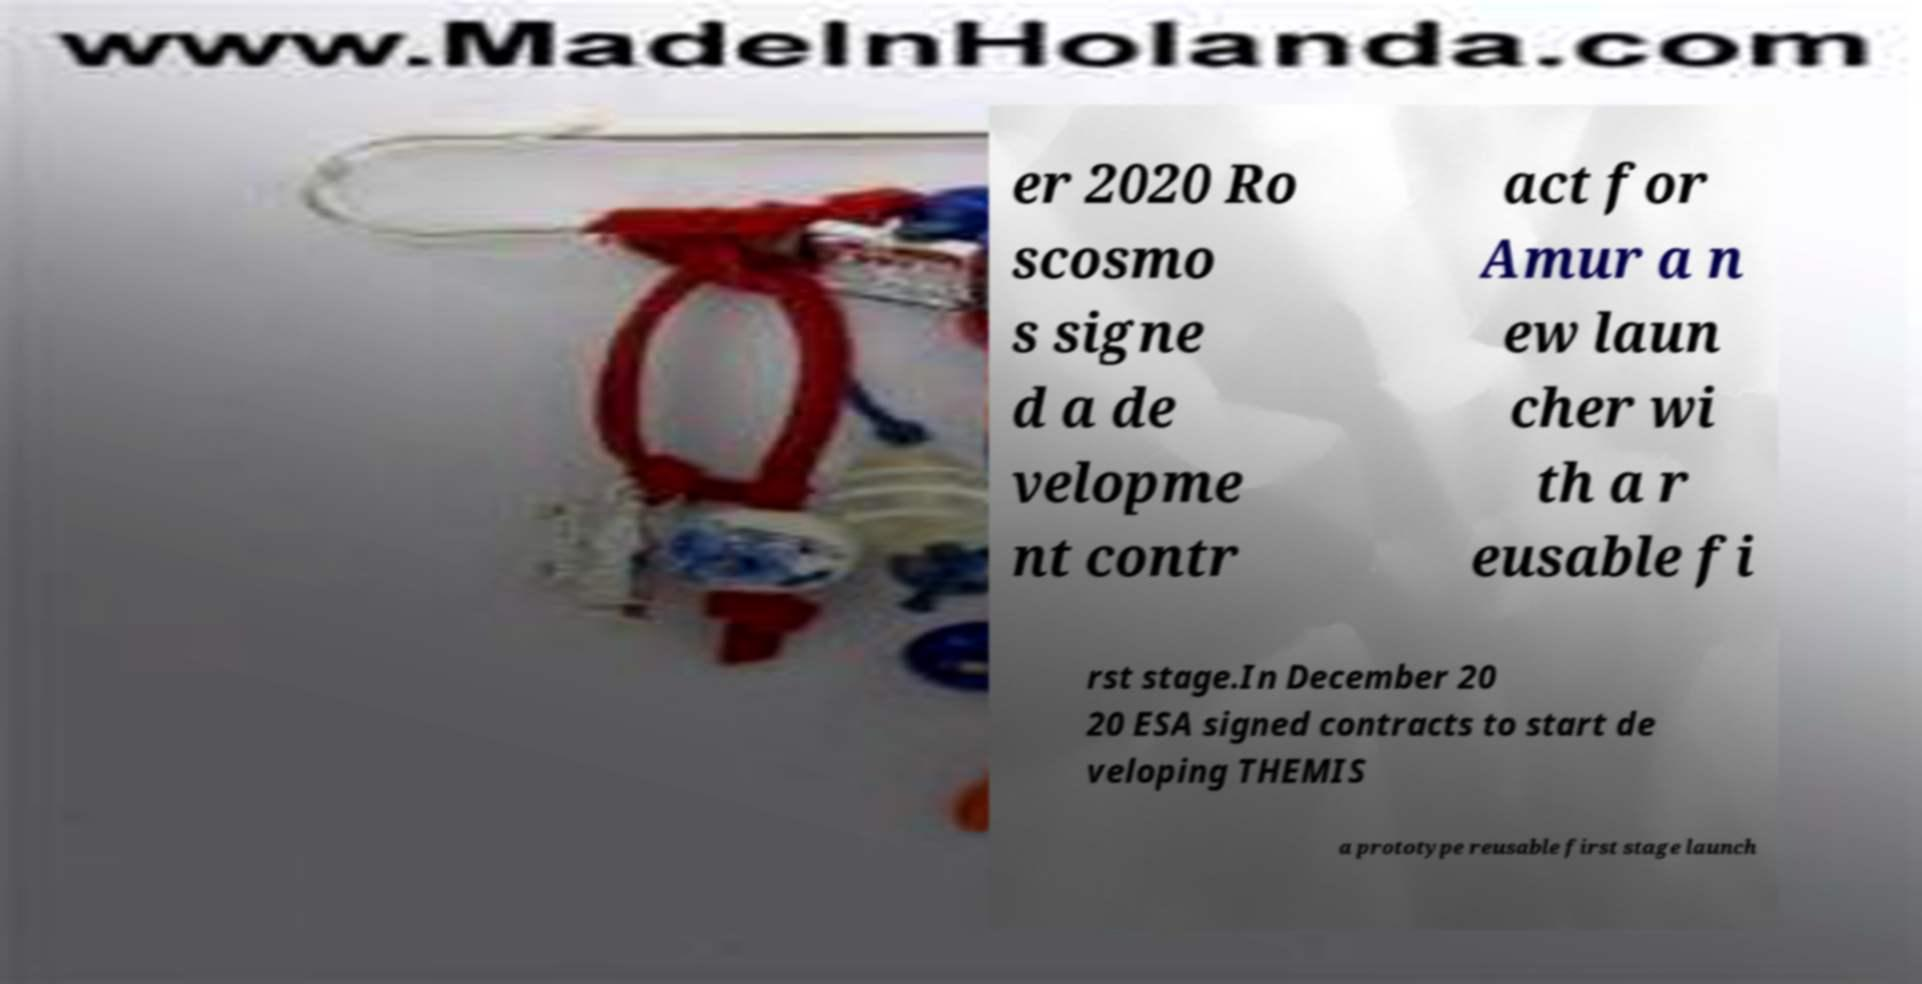Could you extract and type out the text from this image? er 2020 Ro scosmo s signe d a de velopme nt contr act for Amur a n ew laun cher wi th a r eusable fi rst stage.In December 20 20 ESA signed contracts to start de veloping THEMIS a prototype reusable first stage launch 